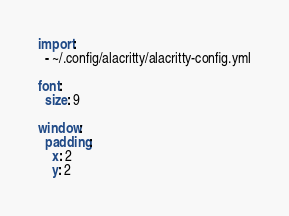<code> <loc_0><loc_0><loc_500><loc_500><_YAML_>import:
  - ~/.config/alacritty/alacritty-config.yml

font:
  size: 9

window:
  padding:
    x: 2
    y: 2
</code> 